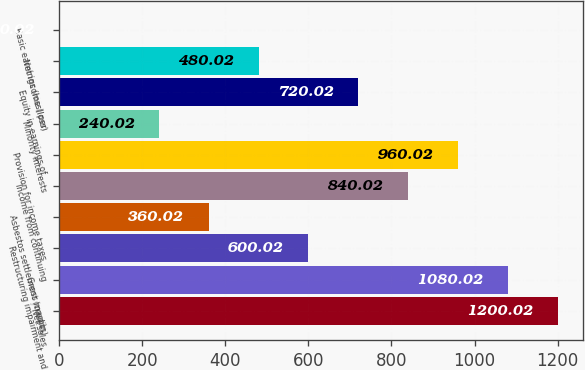<chart> <loc_0><loc_0><loc_500><loc_500><bar_chart><fcel>Net sales<fcel>Gross margin<fcel>Restructuring impairment and<fcel>Asbestos settlement (credits)<fcel>Income from continuing<fcel>Provision for income taxes<fcel>Minority interests<fcel>Equity in earnings of<fcel>Net income (loss)<fcel>Basic earnings (loss) per<nl><fcel>1200.02<fcel>1080.02<fcel>600.02<fcel>360.02<fcel>840.02<fcel>960.02<fcel>240.02<fcel>720.02<fcel>480.02<fcel>0.02<nl></chart> 